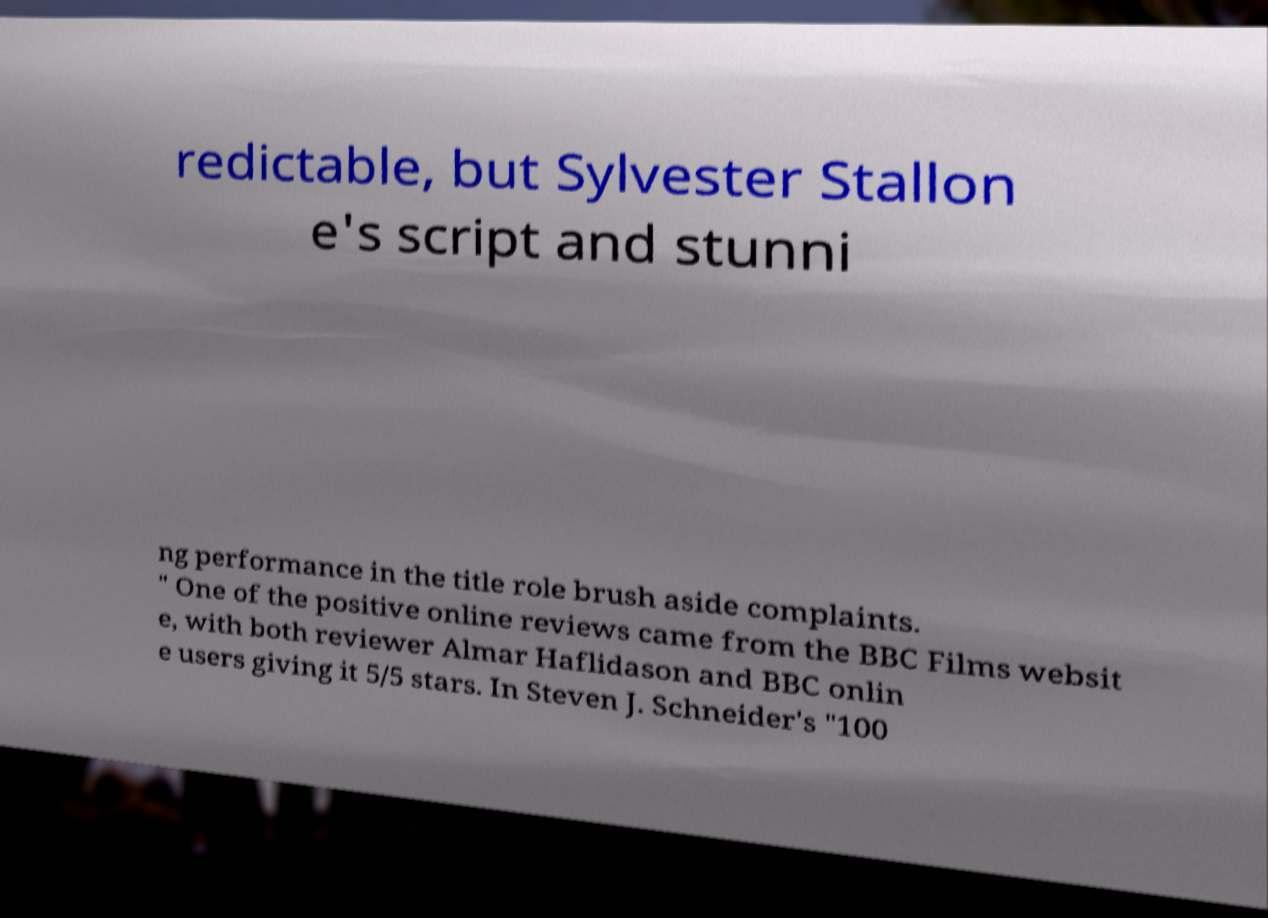Can you accurately transcribe the text from the provided image for me? redictable, but Sylvester Stallon e's script and stunni ng performance in the title role brush aside complaints. " One of the positive online reviews came from the BBC Films websit e, with both reviewer Almar Haflidason and BBC onlin e users giving it 5/5 stars. In Steven J. Schneider's "100 